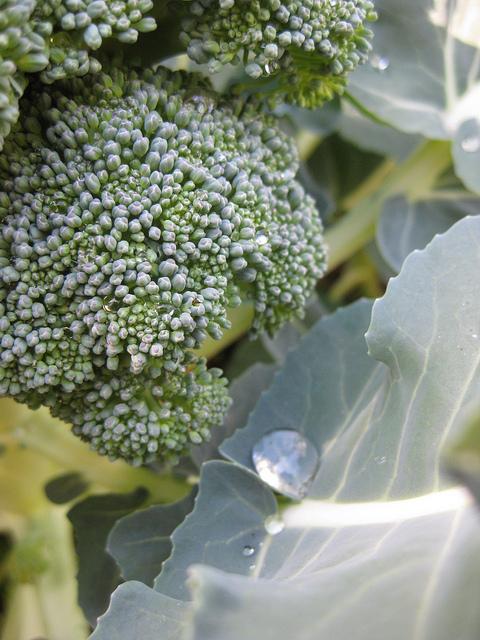Has the Broccoli been washed?
Short answer required. Yes. What is on this broccoli?
Concise answer only. Water. Has the vegetable been picked?
Quick response, please. No. 